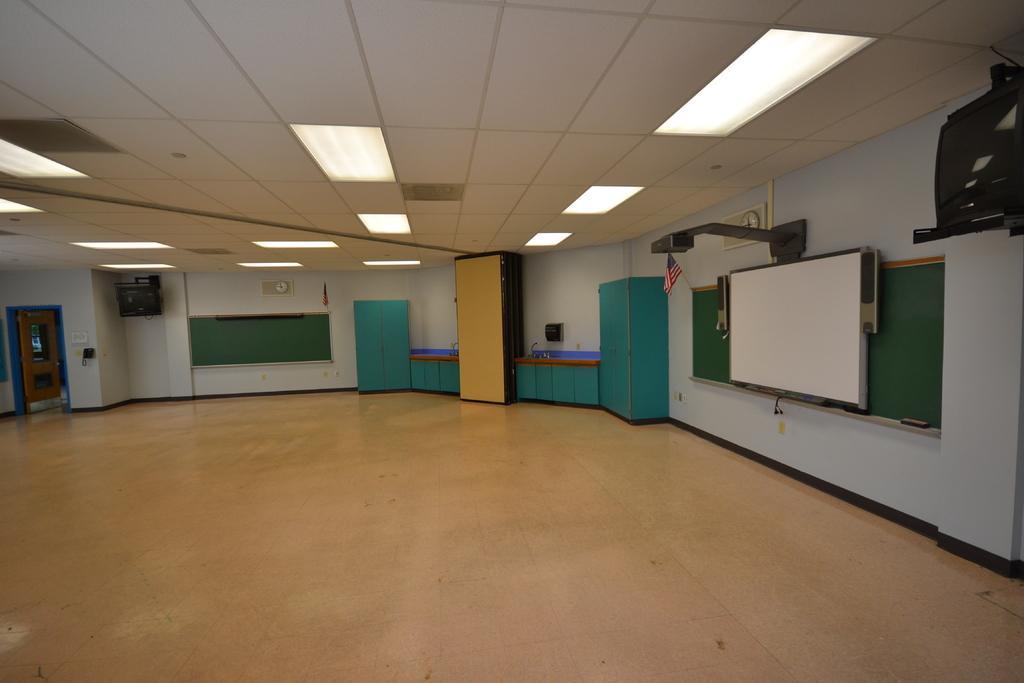Can you describe this image briefly? In a room there are two boards and in front of one of the board there is a projector screen, beside the boards there are cupboards and cabinets, in the background there is a wall and on the left side there is a door beside the wall. 